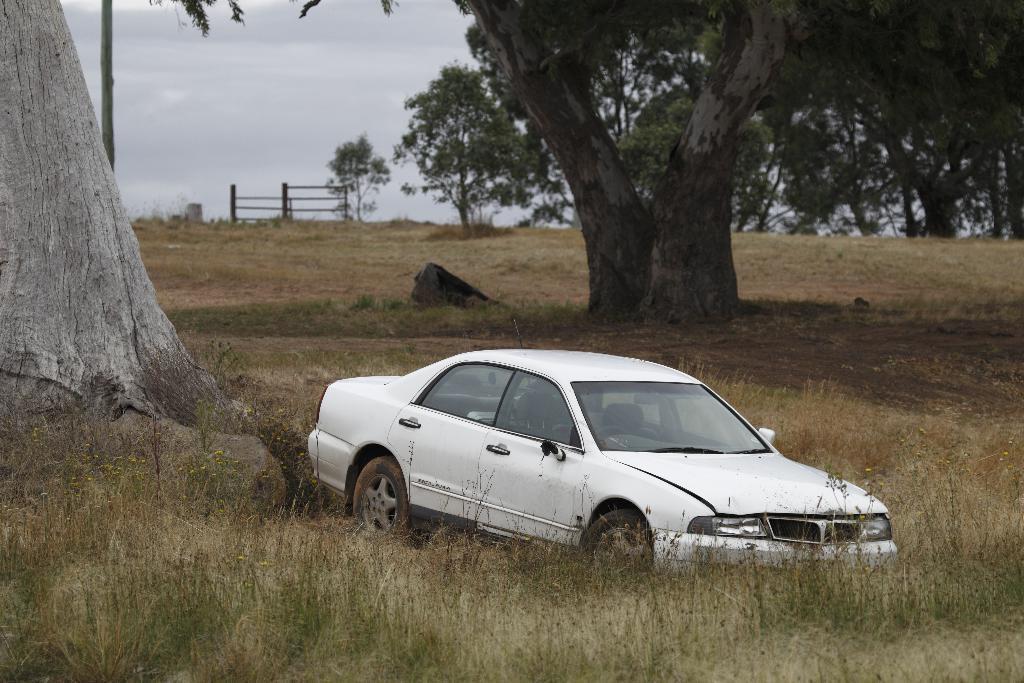Please provide a concise description of this image. In this image we can see a vehicle. In the background of the image there are trees, rock, sky and other objects. On the left side of the image there is a tree and a pole. At the bottom of the image there is the grass, tiny plants and ground. 